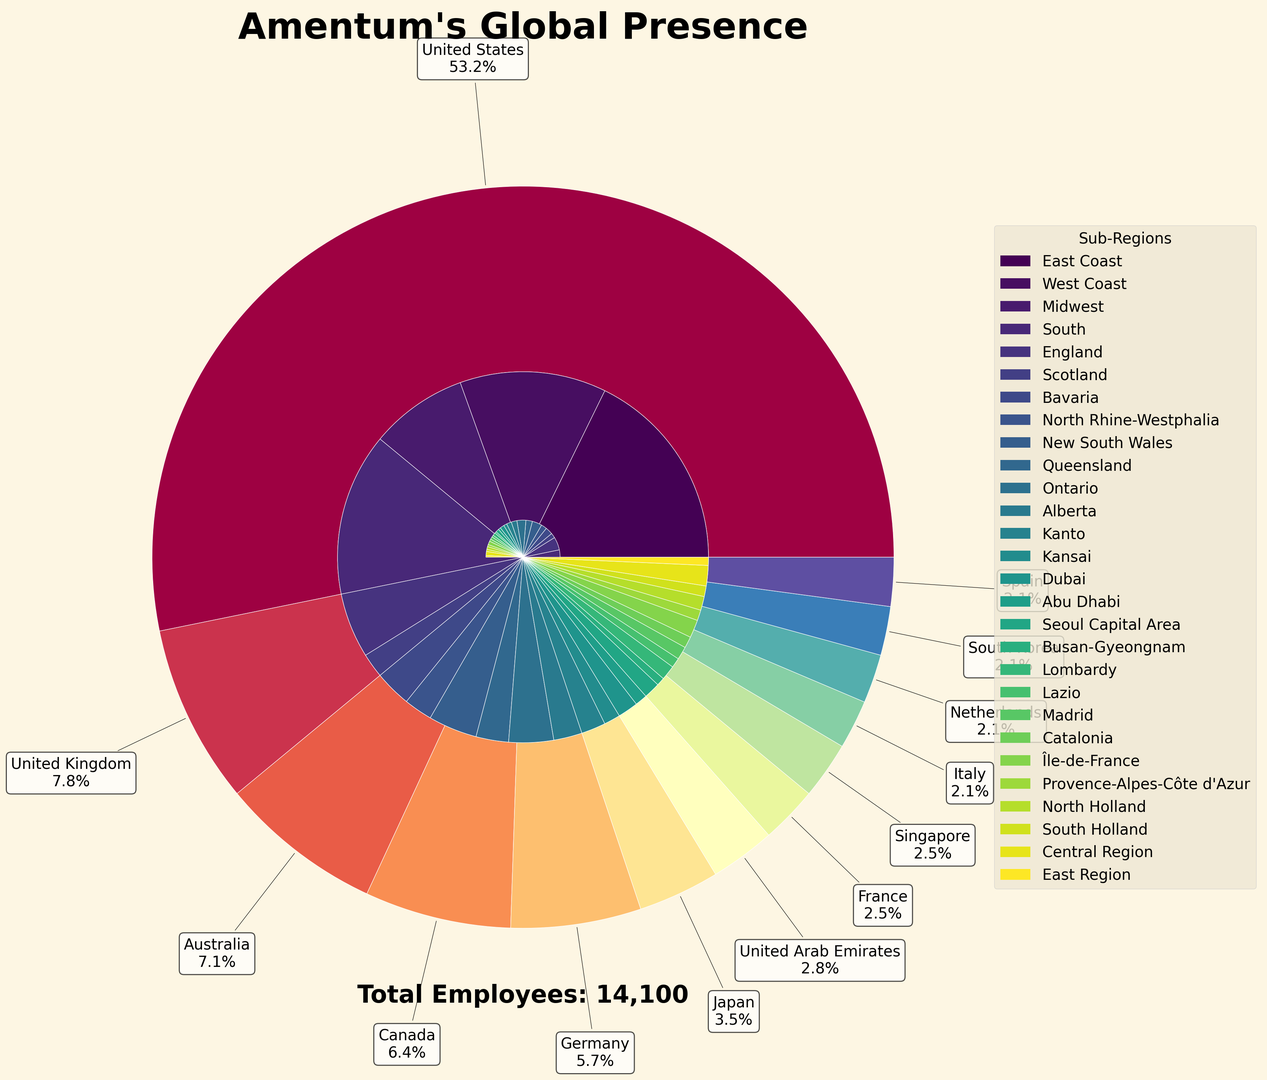Which country has the highest number of employees? The figure shows the number of employees for each country in the outer circle. The United States has the largest segment.
Answer: United States What is the total number of employees in sub-regions within the United Kingdom? Summing the employees shown in the inner circle for England (800) and Scotland (300), gives a total of 1100.
Answer: 1100 Which sub-region in the United States has the fewest employees? By looking at the inner circle segments within the United States, the Midwest has the smallest segment.
Answer: Midwest Compare the number of employees in Queensland, Australia to Alberta, Canada. The figure shows the number of employees in Queensland (400) and Alberta (350); Queensland has more employees.
Answer: Queensland has more How many more employees does Bavaria, Germany have compared to Abu Dhabi, UAE? Bavaria has 450 employees, while Abu Dhabi has 150. The difference is 450 - 150 = 300.
Answer: 300 Which regions in France have a similar number of employees? Inspecting the inner circle for France, Île-de-France (220) and Provence-Alpes-Côte d'Azur (130) compared; they have similar proportions relative to each other.
Answer: None; Île-de-France has more What percentage of Amentum’s total global employees are based in South Korea? From the annotations on the outer circle, South Korea has 300 employees. Summing the total employees from the text (14,100), the percentage is (300/14,100) * 100 ≈ 2.13%.
Answer: 2.13% Which country has a larger share of employees, Japan or the Netherlands? Both Japan and the Netherlands' areas in the outer circle can be compared visually. Japan's segment is slightly larger.
Answer: Japan Calculate the average number of employees per sub-region in Italy. Italy has two sub-regions: Lombardy (180) and Lazio (120). The average is (180 + 120) / 2 = 150.
Answer: 150 What is the visual difference between sub-regions in the same country? Sub-regions within a country share a similar color scheme but differ in size according to their number of employees.
Answer: Sub-regions differ in size, same color scheme 